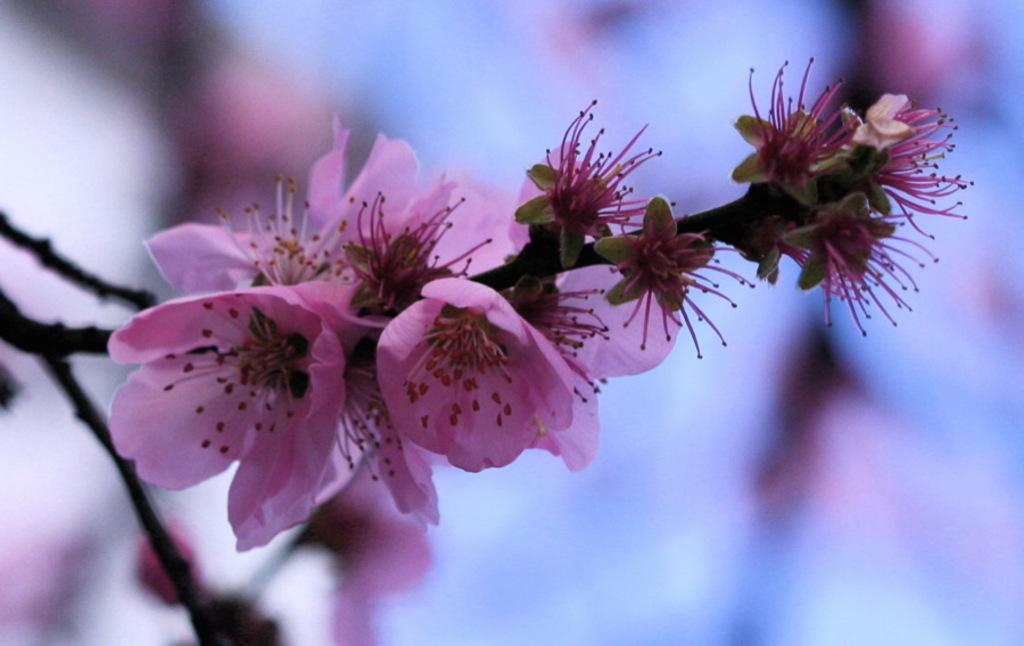What color are the flowers in the image? The flowers in the image are pink colored. Where are the flowers located? The flowers are on a branch. What can be seen on the flowers in the image? Pollen grains are present in the image. What type of crime is being committed by the frog in the image? There is no frog present in the image, and therefore no crime can be committed by a frog. 